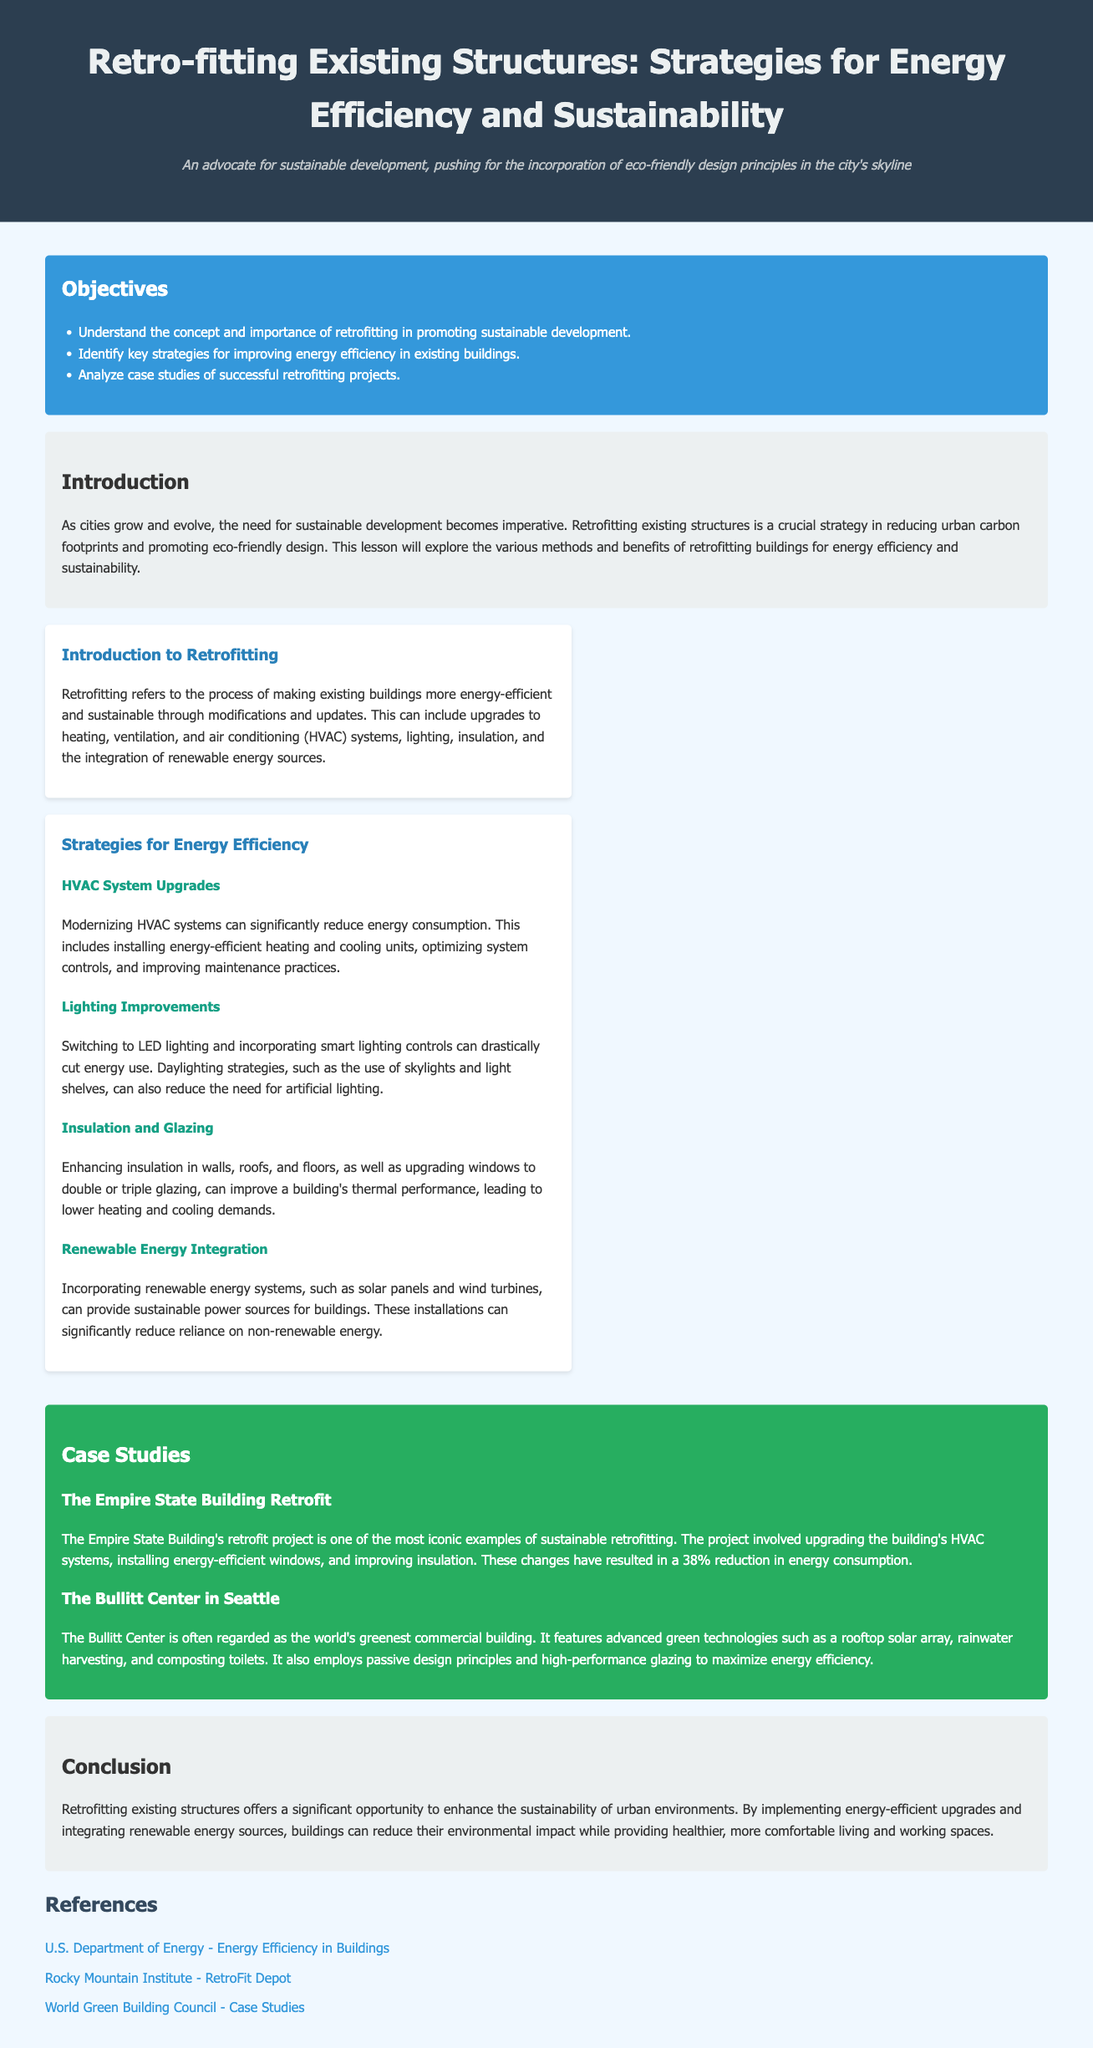what is the title of the lesson plan? The title of the lesson plan is the main heading of the document, which is presented prominently at the top.
Answer: Retro-fitting Existing Structures: Strategies for Energy Efficiency and Sustainability what is one key objective of the lesson plan? The objectives are listed in a section and provide specific goals for understanding the content.
Answer: Understand the concept and importance of retrofitting in promoting sustainable development which building's retrofit project is highlighted as an iconic example? The case studies mention specific buildings that serve as examples, including one that is particularly well-known.
Answer: The Empire State Building Retrofit how much can energy consumption be reduced in the Empire State Building after retrofitting? The document provides a specific percentage that indicates the effectiveness of the retrofit project.
Answer: 38% what feature does the Bullitt Center utilize for sustainability? The case study of the Bullitt Center mentions various technologies that set it apart in terms of sustainability.
Answer: Rooftop solar array what type of systems can modernizing HVAC systems significantly reduce? The discussion on HVAC system upgrades specifies what aspect of energy use is affected by modernization.
Answer: Energy consumption what is the main goal of retrofitting according to the introduction? The introduction emphasizes the overall aim of retrofitting existing structures in the context of sustainable development.
Answer: Reducing urban carbon footprints how many case studies are mentioned in the document? The case studies section outlines the number of specific examples provided in the lesson plan.
Answer: Two 